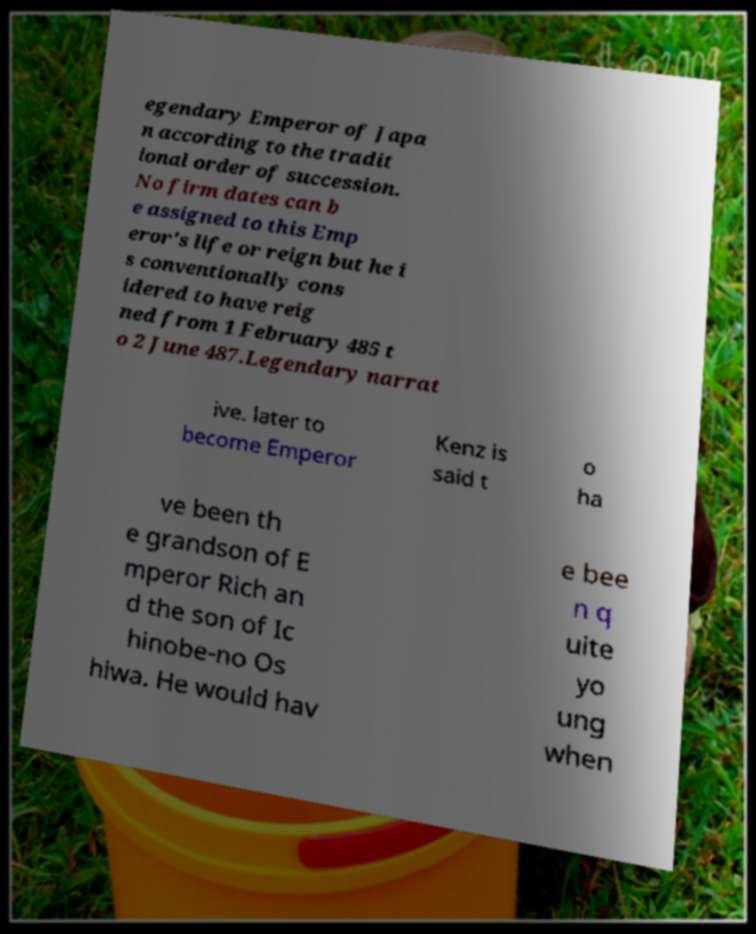Could you assist in decoding the text presented in this image and type it out clearly? egendary Emperor of Japa n according to the tradit ional order of succession. No firm dates can b e assigned to this Emp eror's life or reign but he i s conventionally cons idered to have reig ned from 1 February 485 t o 2 June 487.Legendary narrat ive. later to become Emperor Kenz is said t o ha ve been th e grandson of E mperor Rich an d the son of Ic hinobe-no Os hiwa. He would hav e bee n q uite yo ung when 